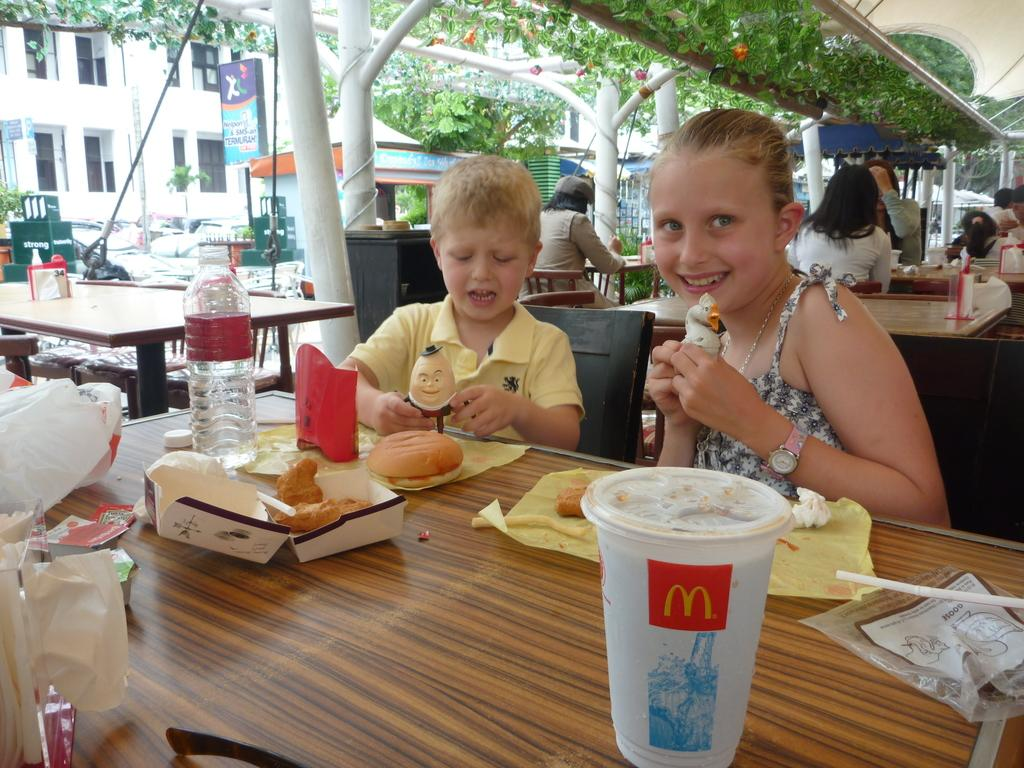Who is present in the image? There are kids in the image. What are the kids doing in the image? The kids are sitting on chairs and eating ice cream. What else can be seen on the table in the image? There is food on the table. Can you describe the setting of the image? The setting appears to be an outdoor restaurant. What type of pen is the deer holding in the image? There is no pen or deer present in the image. 